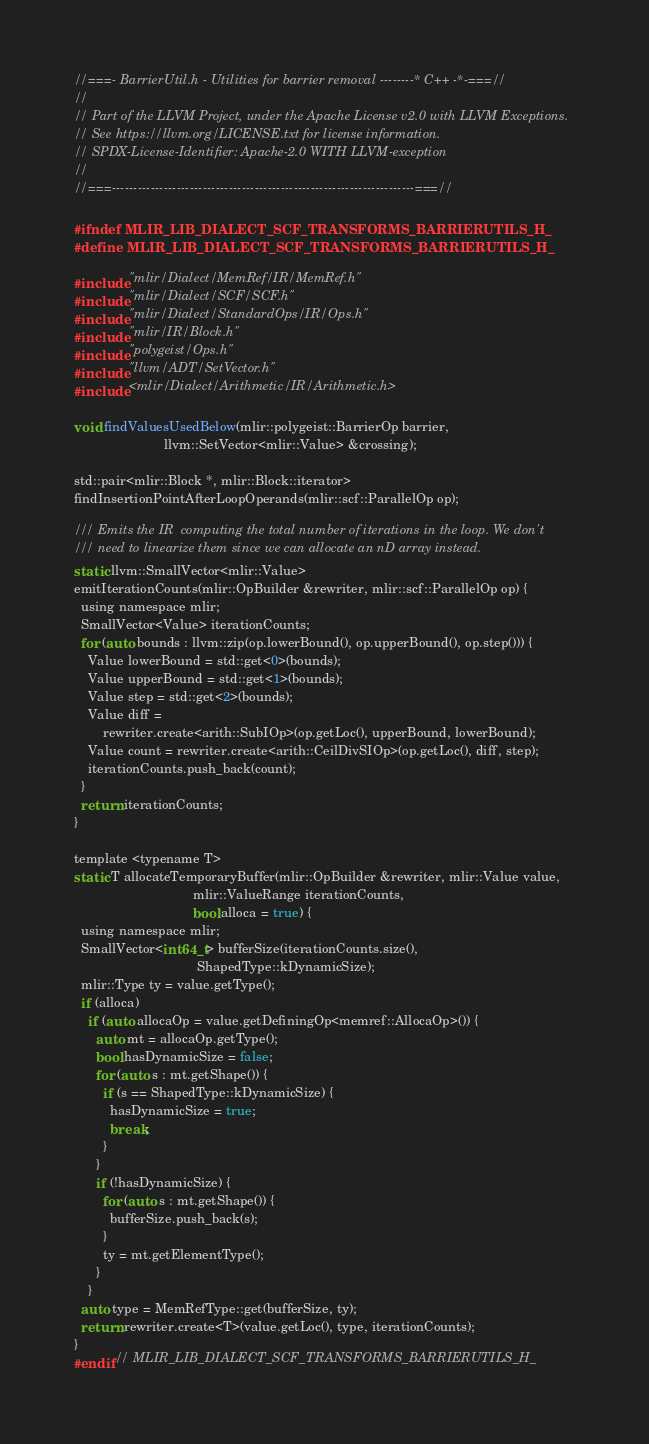Convert code to text. <code><loc_0><loc_0><loc_500><loc_500><_C_>//===- BarrierUtil.h - Utilities for barrier removal --------* C++ -*-===//
//
// Part of the LLVM Project, under the Apache License v2.0 with LLVM Exceptions.
// See https://llvm.org/LICENSE.txt for license information.
// SPDX-License-Identifier: Apache-2.0 WITH LLVM-exception
//
//===----------------------------------------------------------------------===//

#ifndef MLIR_LIB_DIALECT_SCF_TRANSFORMS_BARRIERUTILS_H_
#define MLIR_LIB_DIALECT_SCF_TRANSFORMS_BARRIERUTILS_H_

#include "mlir/Dialect/MemRef/IR/MemRef.h"
#include "mlir/Dialect/SCF/SCF.h"
#include "mlir/Dialect/StandardOps/IR/Ops.h"
#include "mlir/IR/Block.h"
#include "polygeist/Ops.h"
#include "llvm/ADT/SetVector.h"
#include <mlir/Dialect/Arithmetic/IR/Arithmetic.h>

void findValuesUsedBelow(mlir::polygeist::BarrierOp barrier,
                         llvm::SetVector<mlir::Value> &crossing);

std::pair<mlir::Block *, mlir::Block::iterator>
findInsertionPointAfterLoopOperands(mlir::scf::ParallelOp op);

/// Emits the IR  computing the total number of iterations in the loop. We don't
/// need to linearize them since we can allocate an nD array instead.
static llvm::SmallVector<mlir::Value>
emitIterationCounts(mlir::OpBuilder &rewriter, mlir::scf::ParallelOp op) {
  using namespace mlir;
  SmallVector<Value> iterationCounts;
  for (auto bounds : llvm::zip(op.lowerBound(), op.upperBound(), op.step())) {
    Value lowerBound = std::get<0>(bounds);
    Value upperBound = std::get<1>(bounds);
    Value step = std::get<2>(bounds);
    Value diff =
        rewriter.create<arith::SubIOp>(op.getLoc(), upperBound, lowerBound);
    Value count = rewriter.create<arith::CeilDivSIOp>(op.getLoc(), diff, step);
    iterationCounts.push_back(count);
  }
  return iterationCounts;
}

template <typename T>
static T allocateTemporaryBuffer(mlir::OpBuilder &rewriter, mlir::Value value,
                                 mlir::ValueRange iterationCounts,
                                 bool alloca = true) {
  using namespace mlir;
  SmallVector<int64_t> bufferSize(iterationCounts.size(),
                                  ShapedType::kDynamicSize);
  mlir::Type ty = value.getType();
  if (alloca)
    if (auto allocaOp = value.getDefiningOp<memref::AllocaOp>()) {
      auto mt = allocaOp.getType();
      bool hasDynamicSize = false;
      for (auto s : mt.getShape()) {
        if (s == ShapedType::kDynamicSize) {
          hasDynamicSize = true;
          break;
        }
      }
      if (!hasDynamicSize) {
        for (auto s : mt.getShape()) {
          bufferSize.push_back(s);
        }
        ty = mt.getElementType();
      }
    }
  auto type = MemRefType::get(bufferSize, ty);
  return rewriter.create<T>(value.getLoc(), type, iterationCounts);
}
#endif // MLIR_LIB_DIALECT_SCF_TRANSFORMS_BARRIERUTILS_H_
</code> 